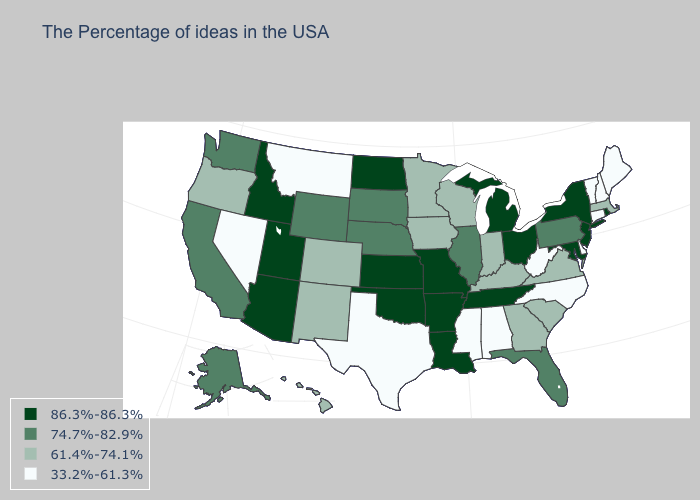Does Delaware have the same value as Vermont?
Give a very brief answer. Yes. Which states have the highest value in the USA?
Write a very short answer. Rhode Island, New York, New Jersey, Maryland, Ohio, Michigan, Tennessee, Louisiana, Missouri, Arkansas, Kansas, Oklahoma, North Dakota, Utah, Arizona, Idaho. Name the states that have a value in the range 74.7%-82.9%?
Concise answer only. Pennsylvania, Florida, Illinois, Nebraska, South Dakota, Wyoming, California, Washington, Alaska. Which states have the highest value in the USA?
Answer briefly. Rhode Island, New York, New Jersey, Maryland, Ohio, Michigan, Tennessee, Louisiana, Missouri, Arkansas, Kansas, Oklahoma, North Dakota, Utah, Arizona, Idaho. Name the states that have a value in the range 74.7%-82.9%?
Concise answer only. Pennsylvania, Florida, Illinois, Nebraska, South Dakota, Wyoming, California, Washington, Alaska. Which states have the highest value in the USA?
Be succinct. Rhode Island, New York, New Jersey, Maryland, Ohio, Michigan, Tennessee, Louisiana, Missouri, Arkansas, Kansas, Oklahoma, North Dakota, Utah, Arizona, Idaho. What is the lowest value in states that border Rhode Island?
Be succinct. 33.2%-61.3%. Does Idaho have a higher value than Kentucky?
Keep it brief. Yes. Which states have the lowest value in the West?
Be succinct. Montana, Nevada. Which states have the lowest value in the USA?
Give a very brief answer. Maine, New Hampshire, Vermont, Connecticut, Delaware, North Carolina, West Virginia, Alabama, Mississippi, Texas, Montana, Nevada. What is the value of Arkansas?
Give a very brief answer. 86.3%-86.3%. Which states hav the highest value in the West?
Quick response, please. Utah, Arizona, Idaho. What is the lowest value in states that border Florida?
Write a very short answer. 33.2%-61.3%. Name the states that have a value in the range 86.3%-86.3%?
Answer briefly. Rhode Island, New York, New Jersey, Maryland, Ohio, Michigan, Tennessee, Louisiana, Missouri, Arkansas, Kansas, Oklahoma, North Dakota, Utah, Arizona, Idaho. What is the highest value in states that border Iowa?
Give a very brief answer. 86.3%-86.3%. 